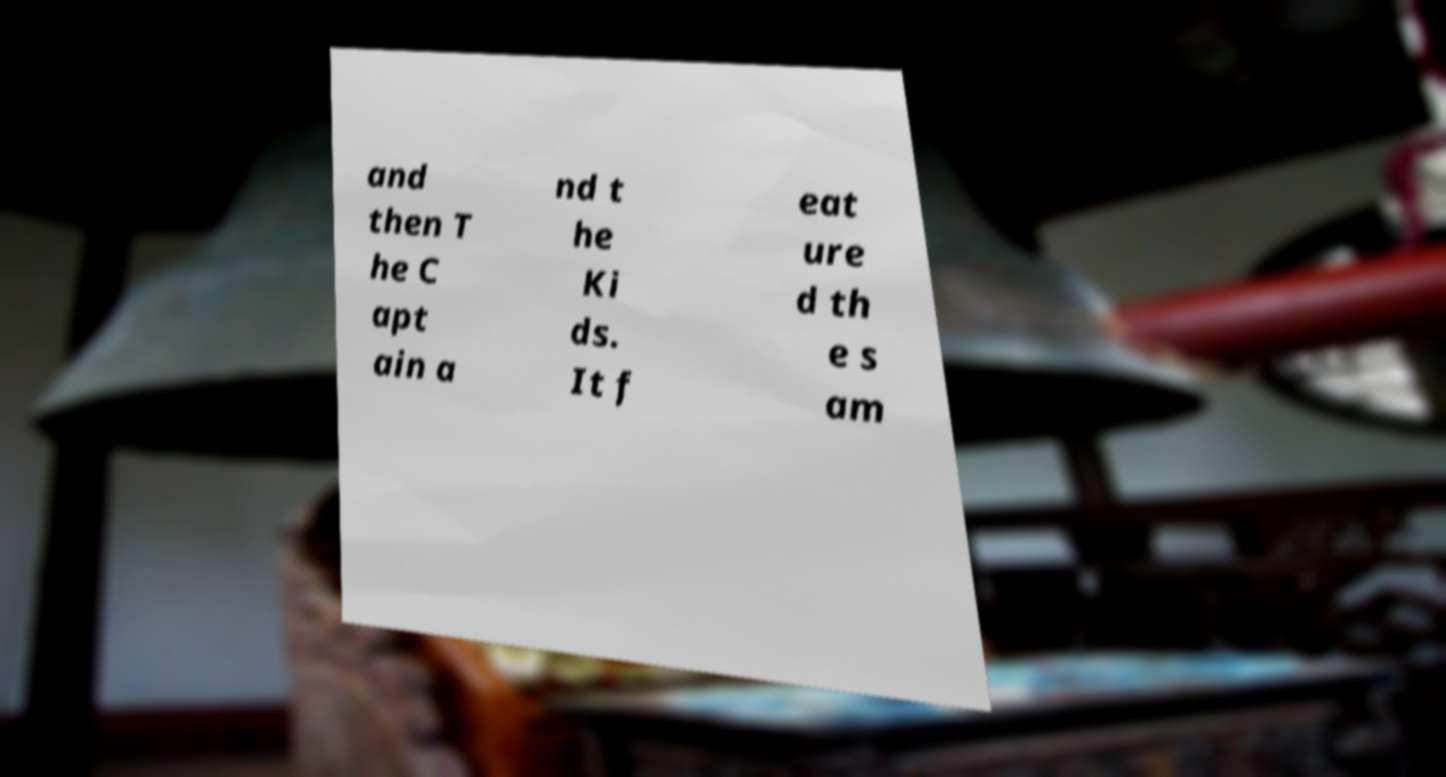Please read and relay the text visible in this image. What does it say? and then T he C apt ain a nd t he Ki ds. It f eat ure d th e s am 